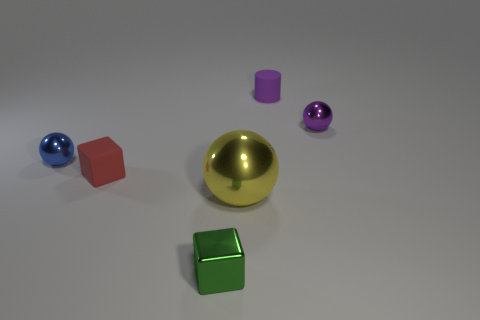Subtract all small purple balls. How many balls are left? 2 Add 1 small purple things. How many objects exist? 7 Subtract all blocks. How many objects are left? 4 Subtract 1 blocks. How many blocks are left? 1 Subtract 0 green spheres. How many objects are left? 6 Subtract all green spheres. Subtract all green blocks. How many spheres are left? 3 Subtract all tiny cubes. Subtract all brown shiny balls. How many objects are left? 4 Add 3 big shiny things. How many big shiny things are left? 4 Add 1 metallic blocks. How many metallic blocks exist? 2 